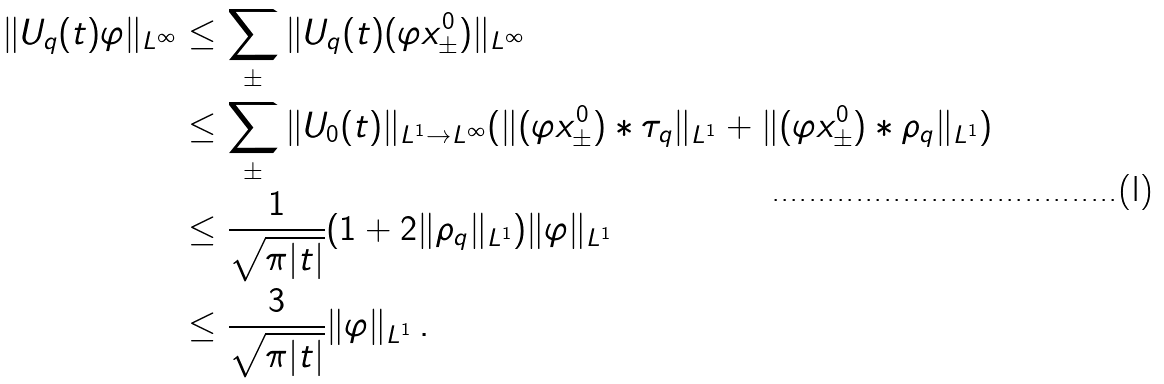<formula> <loc_0><loc_0><loc_500><loc_500>\| U _ { q } ( t ) \varphi \| _ { L ^ { \infty } } & \leq \sum _ { \pm } \| U _ { q } ( t ) ( \varphi x _ { \pm } ^ { 0 } ) \| _ { L ^ { \infty } } \\ & \leq \sum _ { \pm } \| U _ { 0 } ( t ) \| _ { L ^ { 1 } \rightarrow L ^ { \infty } } ( \| ( \varphi x _ { \pm } ^ { 0 } ) * \tau _ { q } \| _ { L ^ { 1 } } + \| ( \varphi x _ { \pm } ^ { 0 } ) * \rho _ { q } \| _ { L ^ { 1 } } ) \\ & \leq \frac { 1 } { \sqrt { \pi | t | } } ( 1 + 2 \| \rho _ { q } \| _ { L ^ { 1 } } ) \| \varphi \| _ { L ^ { 1 } } \\ & \leq \frac { 3 } { \sqrt { \pi | t | } } \| \varphi \| _ { L ^ { 1 } } \, .</formula> 